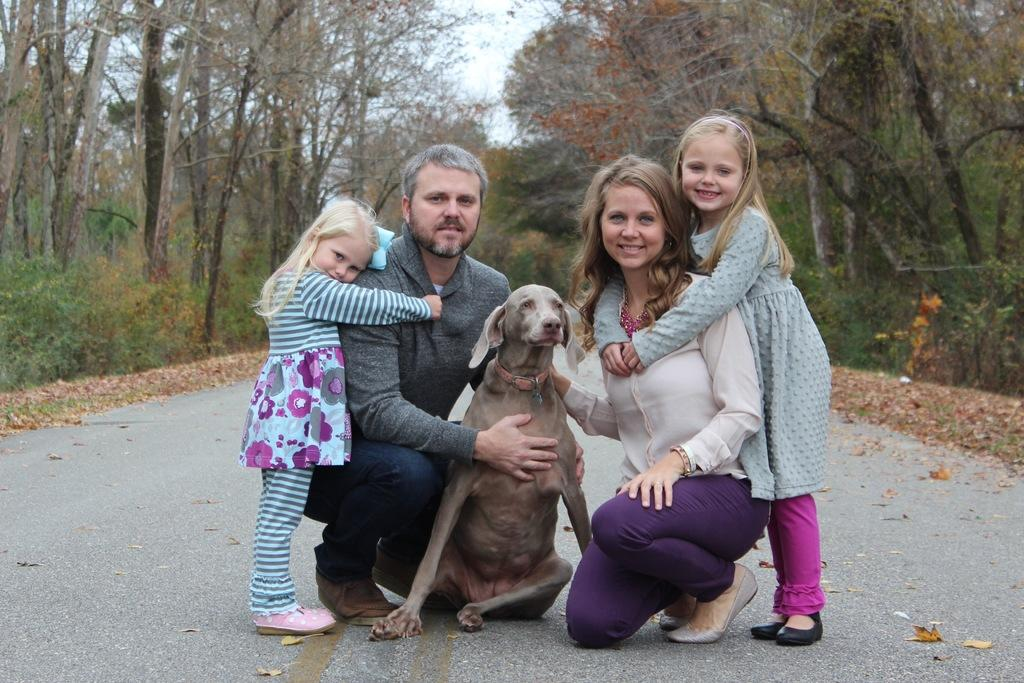How many people are present in the image? There is a man, a woman, and two girls in the image. What type of animal is present in the image? There is a dog in the image. Where are the subjects located in the image? The subjects are in the middle of a forest. What type of cork can be seen in the image? There is no cork present in the image. What impulse might have led the subjects to gather in the forest? The image does not provide information about the subjects' motivations or impulses for gathering in the forest. 